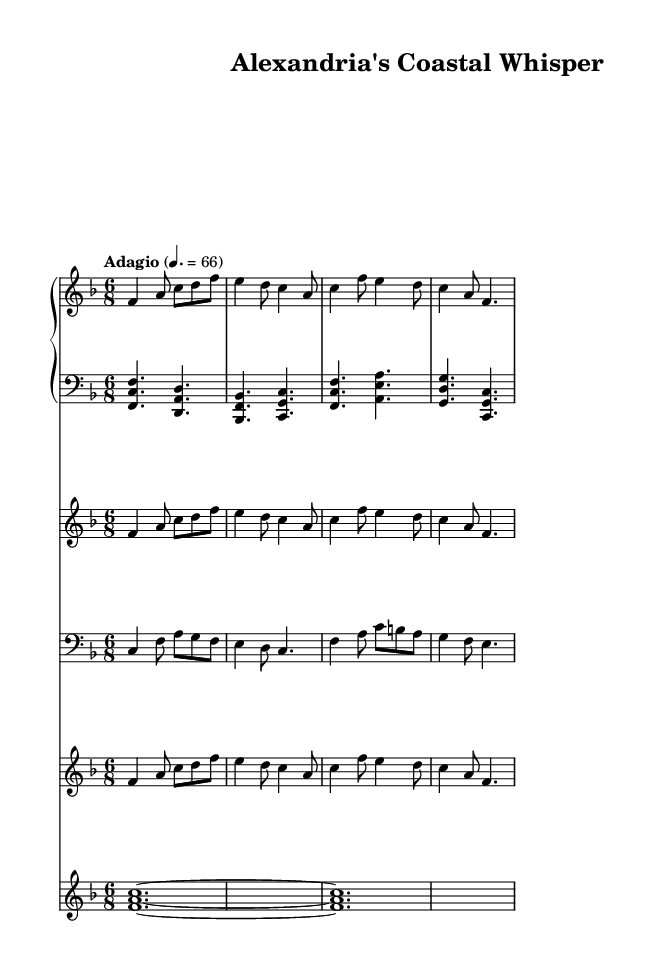What is the key signature of this music? The key signature indicates two flats, which identifies the piece as being in F major.
Answer: F major What is the time signature of this music? The time signature shown at the beginning of the music is 6/8, which means there are six eighth notes per measure.
Answer: 6/8 What is the indicated tempo of the music? The tempo marking specifies "Adagio" with a metronome setting of 66 beats per minute, indicating a slow pace.
Answer: Adagio, 66 How many instruments are featured in this score? The score contains a piano (two staves), a violin, a cello, a flute, and a synthesizer, totaling five instruments.
Answer: Five instruments What kind of synthesizer sound is used in this piece? The synthesizer part is labeled to use a "pad 2 (warm)" sound, which suggests a smooth and rich texture typical for ambient music.
Answer: Pad 2 (warm) Which instrument plays the counter melody? The cello is designated to play the counter melody, as indicated by the staff and the written part.
Answer: Cello What is the overall mood conveyed by the music as indicated by the tempo and style? The combination of the adagio tempo, major key, and ambient soundscapes creates a serene and contemplative mood typical of soundtracks capturing natural beauty.
Answer: Serene and contemplative 